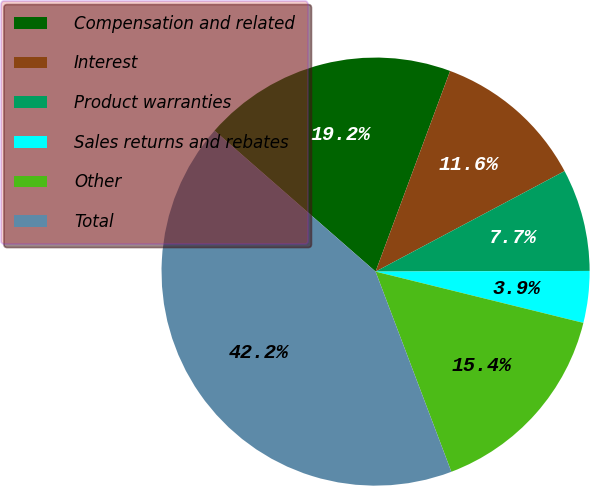<chart> <loc_0><loc_0><loc_500><loc_500><pie_chart><fcel>Compensation and related<fcel>Interest<fcel>Product warranties<fcel>Sales returns and rebates<fcel>Other<fcel>Total<nl><fcel>19.22%<fcel>11.56%<fcel>7.73%<fcel>3.9%<fcel>15.39%<fcel>42.2%<nl></chart> 